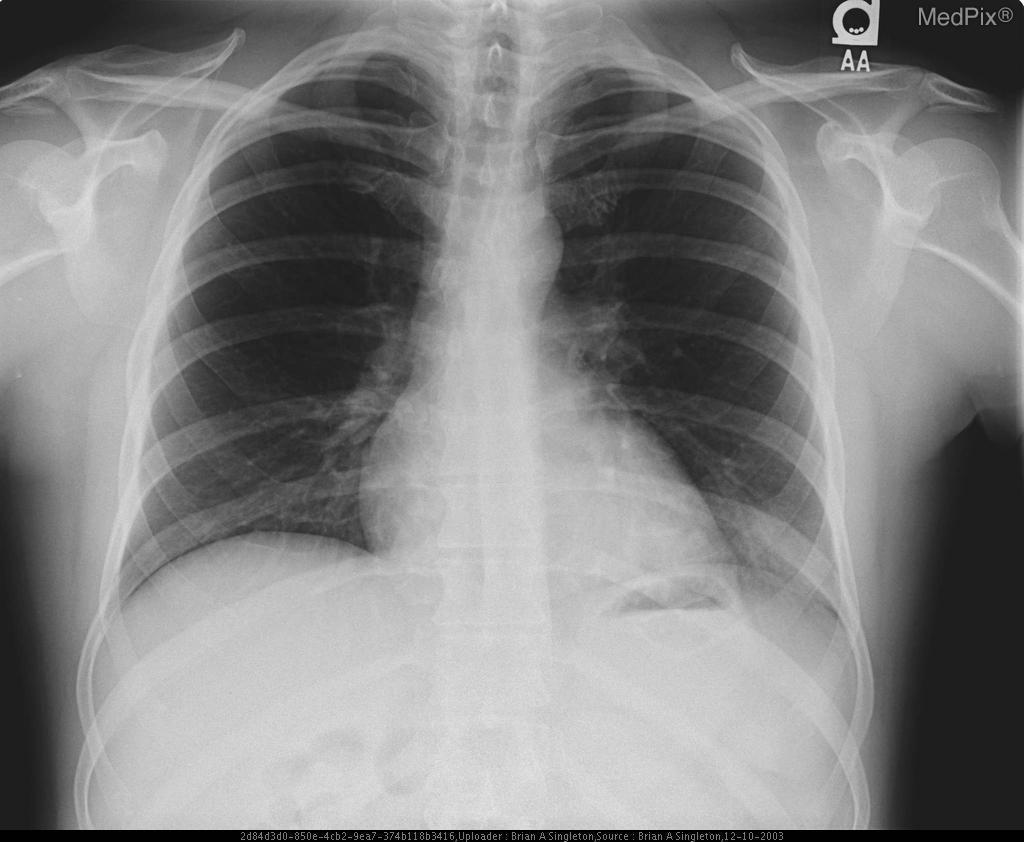Is there consolidation in the lungs?
Concise answer only. No. Name one abnormality in the radiograph.
Keep it brief. Increased opacity in the left retrocardiac region. What is one abnormality that can be seen in the image?
Concise answer only. Increased opacity in the left retrocardiac region. Are the airway walls thickened in the bases?
Answer briefly. Yes. Is there increased airway wall thickening of the bilateral bases?
Quick response, please. Yes. Are there abnormalities?
Concise answer only. Yes. Is anything wrong in this image?
Give a very brief answer. Yes. 